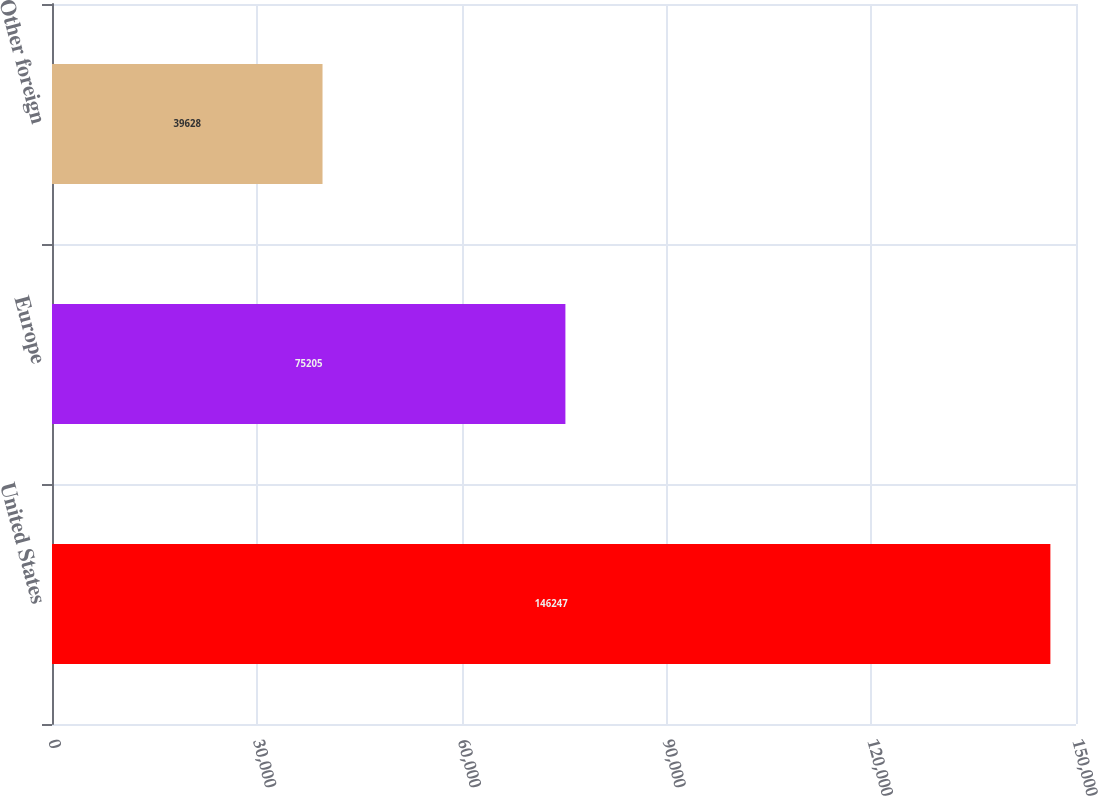Convert chart. <chart><loc_0><loc_0><loc_500><loc_500><bar_chart><fcel>United States<fcel>Europe<fcel>Other foreign<nl><fcel>146247<fcel>75205<fcel>39628<nl></chart> 